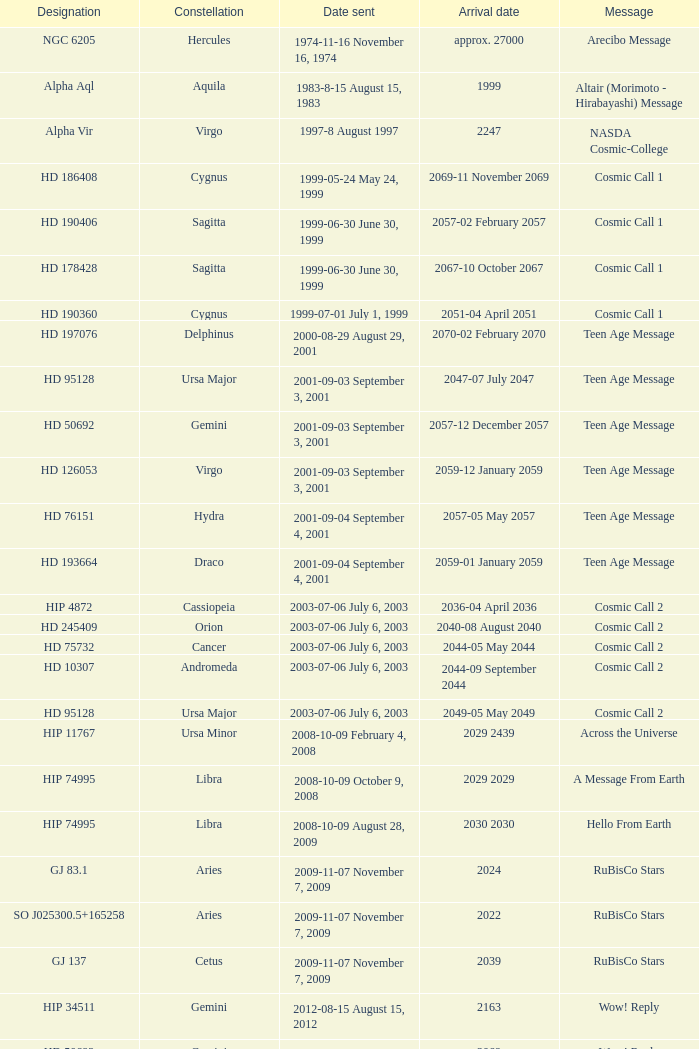Where is Hip 4872? Cassiopeia. 